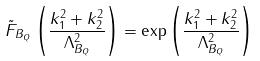<formula> <loc_0><loc_0><loc_500><loc_500>\tilde { F } _ { B _ { Q } } \left ( \frac { k ^ { 2 } _ { 1 } + k ^ { 2 } _ { 2 } } { \Lambda ^ { 2 } _ { B _ { Q } } } \right ) = \exp \left ( \frac { k _ { 1 } ^ { 2 } + k _ { 2 } ^ { 2 } } { \Lambda _ { B _ { Q } } ^ { 2 } } \right )</formula> 